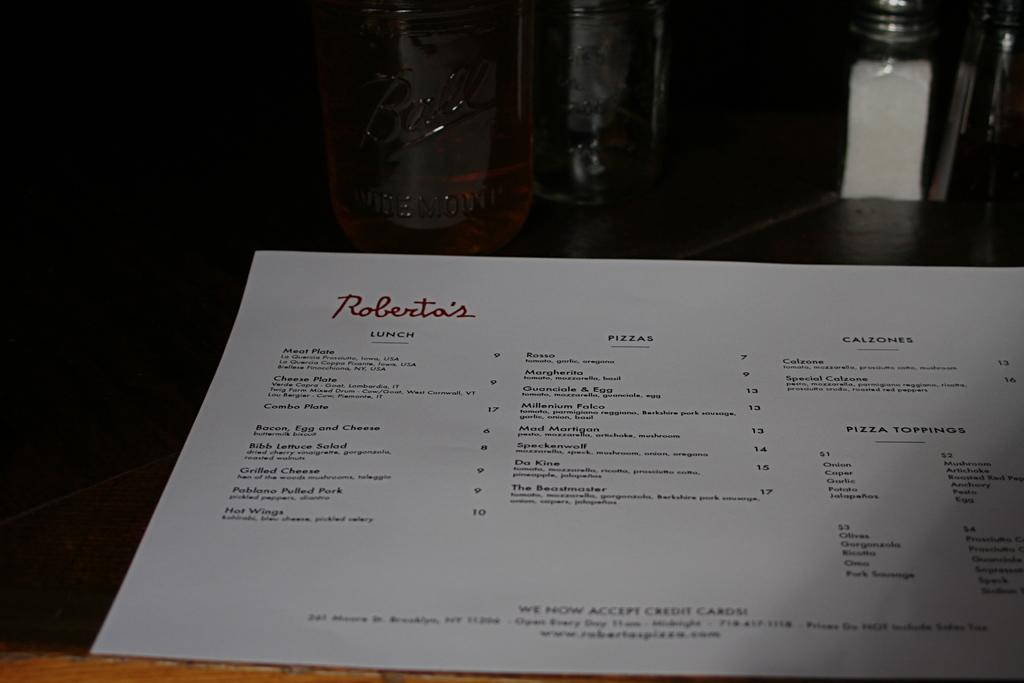<image>
Share a concise interpretation of the image provided. Bacon, Egg and Cheese can be ordered at Roberto's restaurant. 